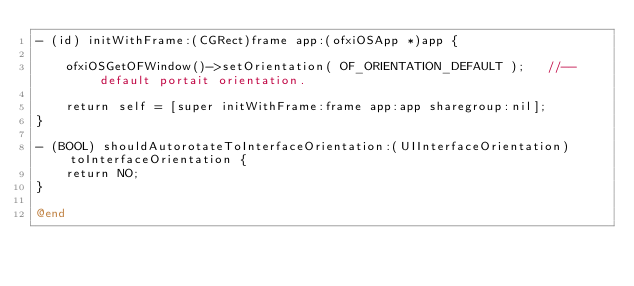<code> <loc_0><loc_0><loc_500><loc_500><_ObjectiveC_>- (id) initWithFrame:(CGRect)frame app:(ofxiOSApp *)app {
    
    ofxiOSGetOFWindow()->setOrientation( OF_ORIENTATION_DEFAULT );   //-- default portait orientation.    
    
    return self = [super initWithFrame:frame app:app sharegroup:nil];
}

- (BOOL) shouldAutorotateToInterfaceOrientation:(UIInterfaceOrientation)toInterfaceOrientation {
    return NO;
}

@end
</code> 